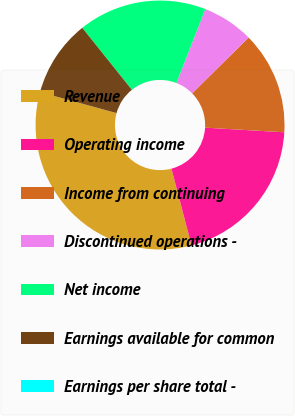<chart> <loc_0><loc_0><loc_500><loc_500><pie_chart><fcel>Revenue<fcel>Operating income<fcel>Income from continuing<fcel>Discontinued operations -<fcel>Net income<fcel>Earnings available for common<fcel>Earnings per share total -<nl><fcel>33.33%<fcel>20.0%<fcel>13.33%<fcel>6.67%<fcel>16.67%<fcel>10.0%<fcel>0.0%<nl></chart> 